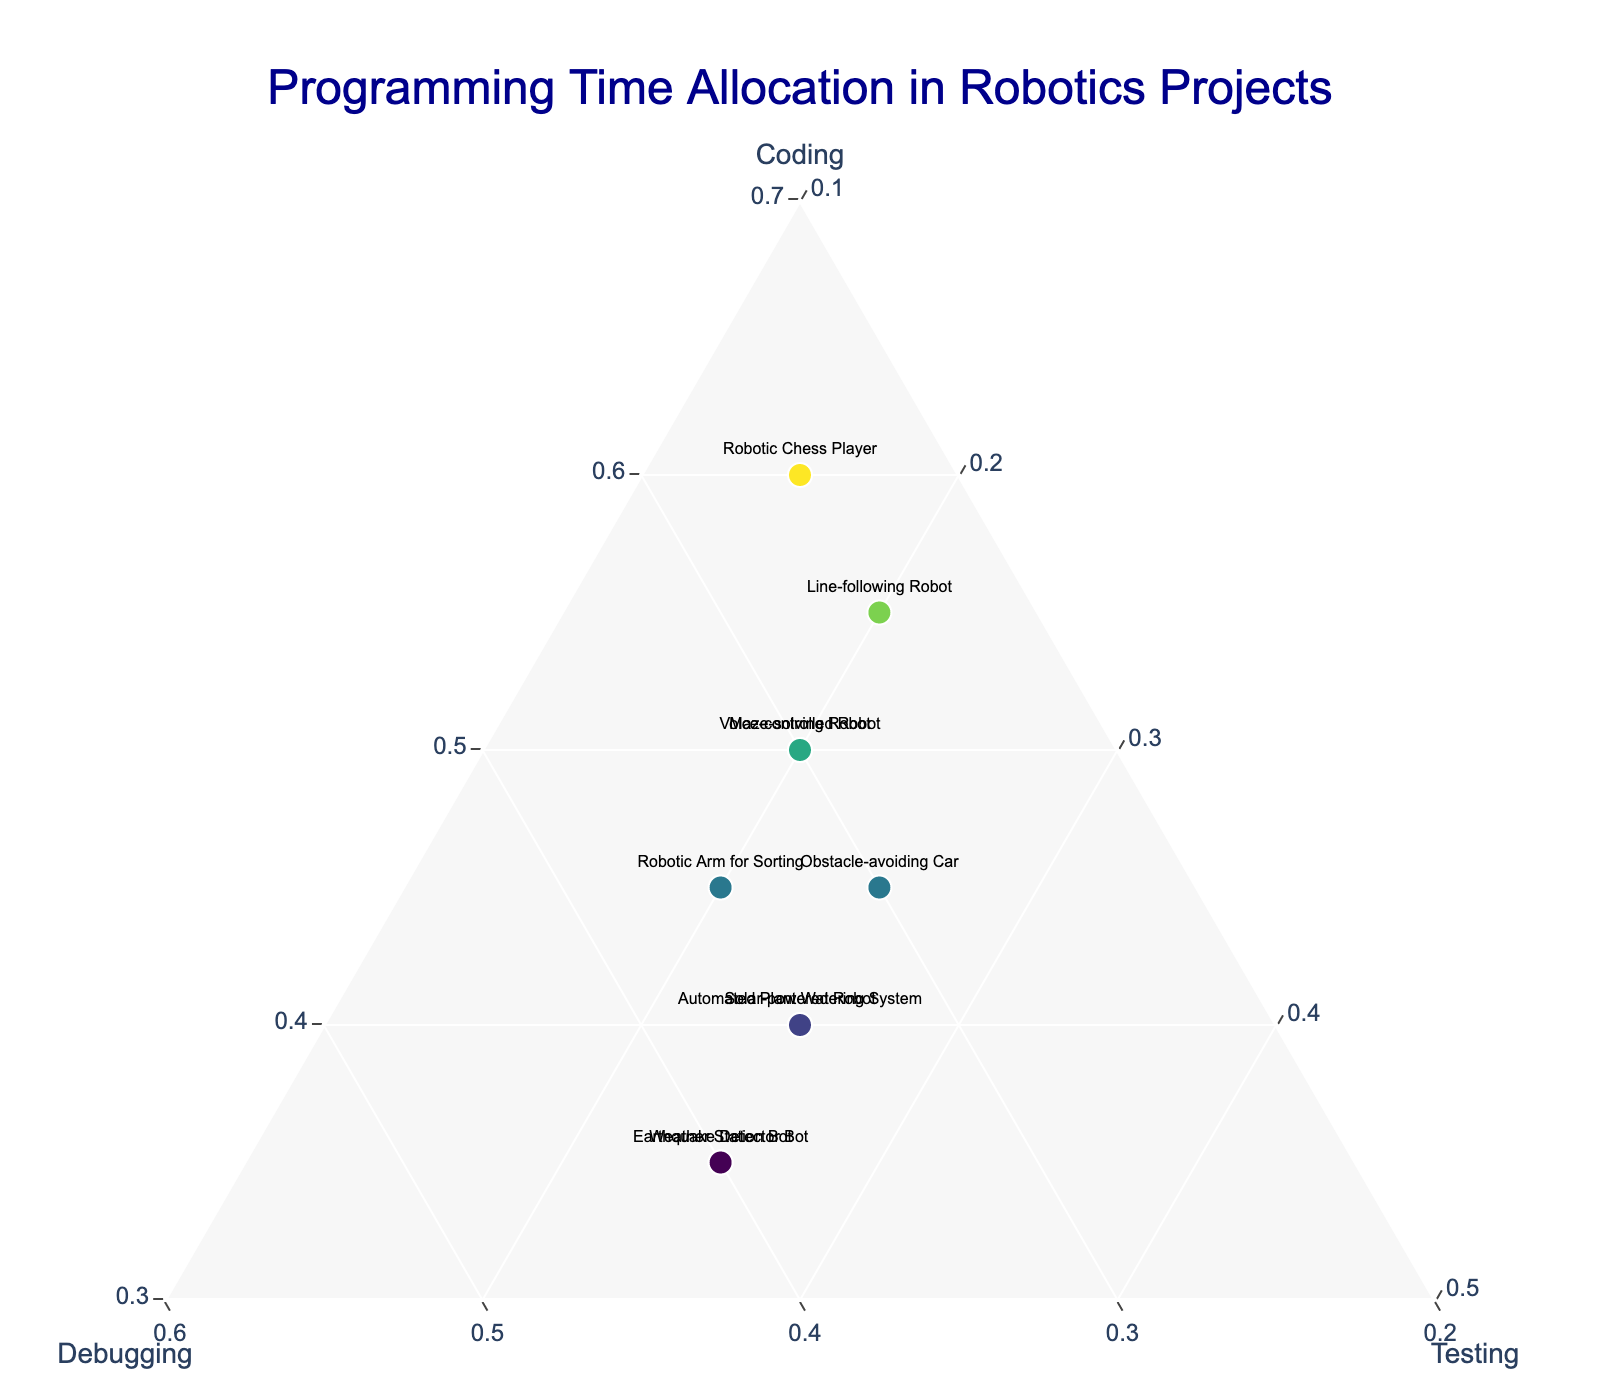What's the title of the figure? Look at the top of the figure, where the title is typically displayed.
Answer: Programming Time Allocation in Robotics Projects What does the greenish color represent in the markers? In the ternary plot, color intensity often represents the values of a variable; here, greenish hues likely indicate the proportion of coding time.
Answer: Coding Which project allocates the highest percentage to debugging? Identify the project marker located closest to the "Debugging" axis in the ternary plot. According to the data, this project allocates 40% to debugging.
Answer: Weather Station Bot How many projects have equal time allocation for debugging and testing? Look for markers where the ratios of debugging and testing are the same. According to the data, these projects have equal proportions of 35% for debugging and testing.
Answer: Automated Plant Watering System, Solar-powered Robot, Earthquake Detector Bot (3 projects) Which project has the most balanced time allocation? The most balanced allocation would be closest to the center of the ternary plot, indicating similar proportions for coding, debugging, and testing. According to the data, the project with values close to 45%, 30%, 25% is the best candidate.
Answer: Obstacle-avoiding Car Is coding time generally higher than debugging time across the projects? Compare the coding and debugging proportions for each project. If the majority have higher coding times, then coding is generally higher.
Answer: Yes What's the combined percentage of debugging and testing for the Line-following Robot? Sum up the debugging and testing percentages for this specific project.
Answer: 25% + 20% = 45% Which project dedicates the least time to testing? Locate the marker closest to the "Testing" axis indicating the smallest proportion. According to the data, this value is 15%.
Answer: Robotic Chess Player For the Maze-solving Robot, how does the time allocation for coding compare to debugging? Look at the positions along the "Coding" and "Debugging" axes for this project. According to the data, coding is allocated 50% and debugging 30%.
Answer: Coding time is higher than debugging Which project is nearest to equal distribution among coding, debugging, and testing, and what are the approximate percentages for this project? Locate the marker closest to the center of the ternary plot and read the values. According to the data, the project with values roughly 45%, 30%, 25% is balancing well.
Answer: Obstacle-avoiding Car: Coding 45%, Debugging 30%, Testing 25% 